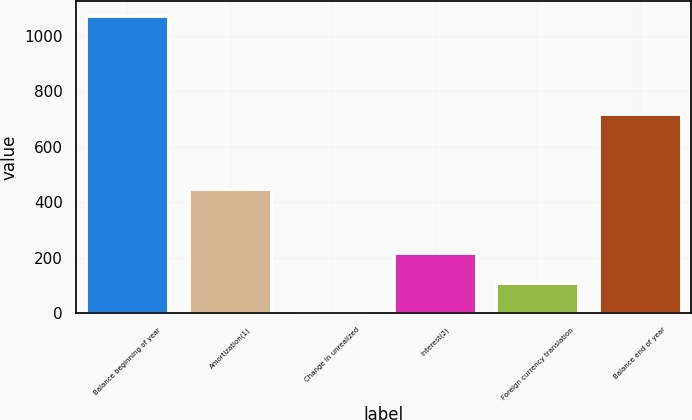Convert chart to OTSL. <chart><loc_0><loc_0><loc_500><loc_500><bar_chart><fcel>Balance beginning of year<fcel>Amortization(1)<fcel>Change in unrealized<fcel>Interest(2)<fcel>Foreign currency translation<fcel>Balance end of year<nl><fcel>1072<fcel>448<fcel>3<fcel>216.8<fcel>109.9<fcel>719<nl></chart> 